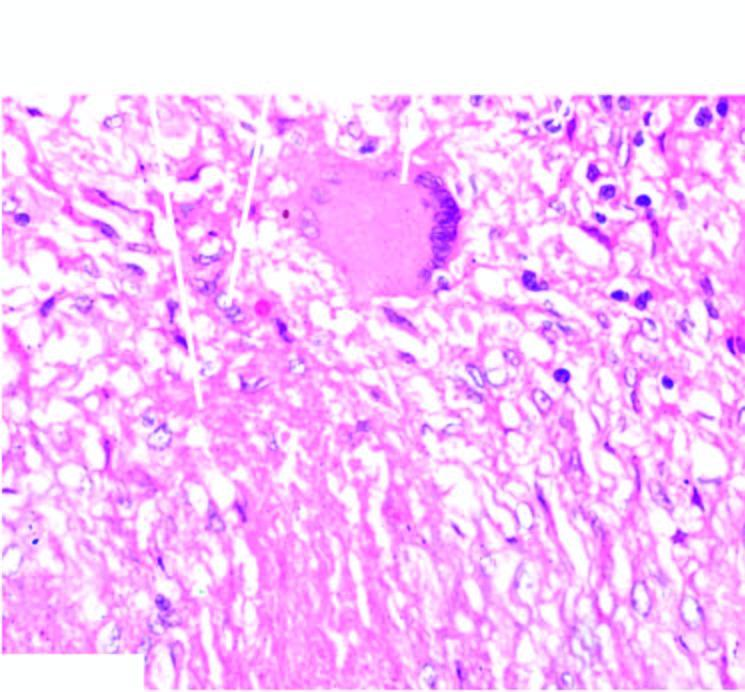s part of the oesophagus which is normally lined by squamous epithelium central caseation necrosis, surrounded by elongated epithelioid cells having characteristic slipper-shaped nuclei, with interspersed langhans ' giant cells?
Answer the question using a single word or phrase. No 